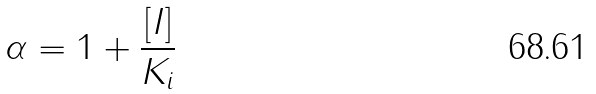Convert formula to latex. <formula><loc_0><loc_0><loc_500><loc_500>\alpha = 1 + \frac { [ I ] } { K _ { i } }</formula> 